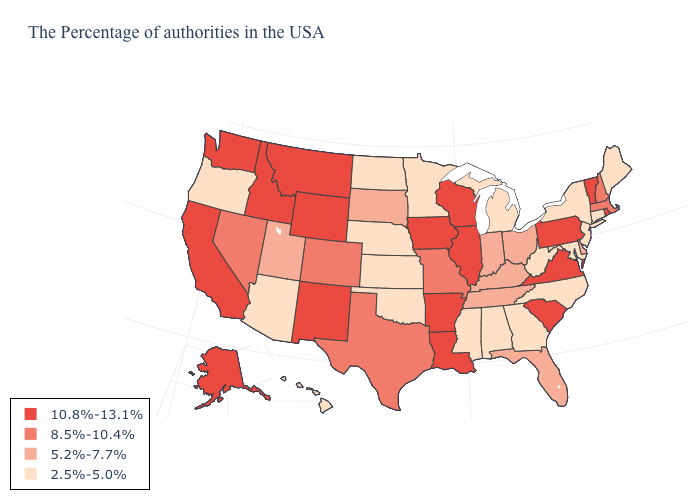Name the states that have a value in the range 10.8%-13.1%?
Be succinct. Rhode Island, Vermont, Pennsylvania, Virginia, South Carolina, Wisconsin, Illinois, Louisiana, Arkansas, Iowa, Wyoming, New Mexico, Montana, Idaho, California, Washington, Alaska. Which states hav the highest value in the West?
Keep it brief. Wyoming, New Mexico, Montana, Idaho, California, Washington, Alaska. What is the value of New Hampshire?
Quick response, please. 8.5%-10.4%. Does Iowa have the highest value in the USA?
Be succinct. Yes. Does the map have missing data?
Quick response, please. No. What is the lowest value in the USA?
Short answer required. 2.5%-5.0%. Which states have the lowest value in the Northeast?
Be succinct. Maine, Connecticut, New York, New Jersey. Does Florida have a higher value than Missouri?
Be succinct. No. What is the value of Wyoming?
Keep it brief. 10.8%-13.1%. What is the value of Indiana?
Keep it brief. 5.2%-7.7%. What is the lowest value in states that border Illinois?
Short answer required. 5.2%-7.7%. What is the value of Idaho?
Write a very short answer. 10.8%-13.1%. Name the states that have a value in the range 8.5%-10.4%?
Quick response, please. Massachusetts, New Hampshire, Missouri, Texas, Colorado, Nevada. What is the value of Missouri?
Answer briefly. 8.5%-10.4%. 